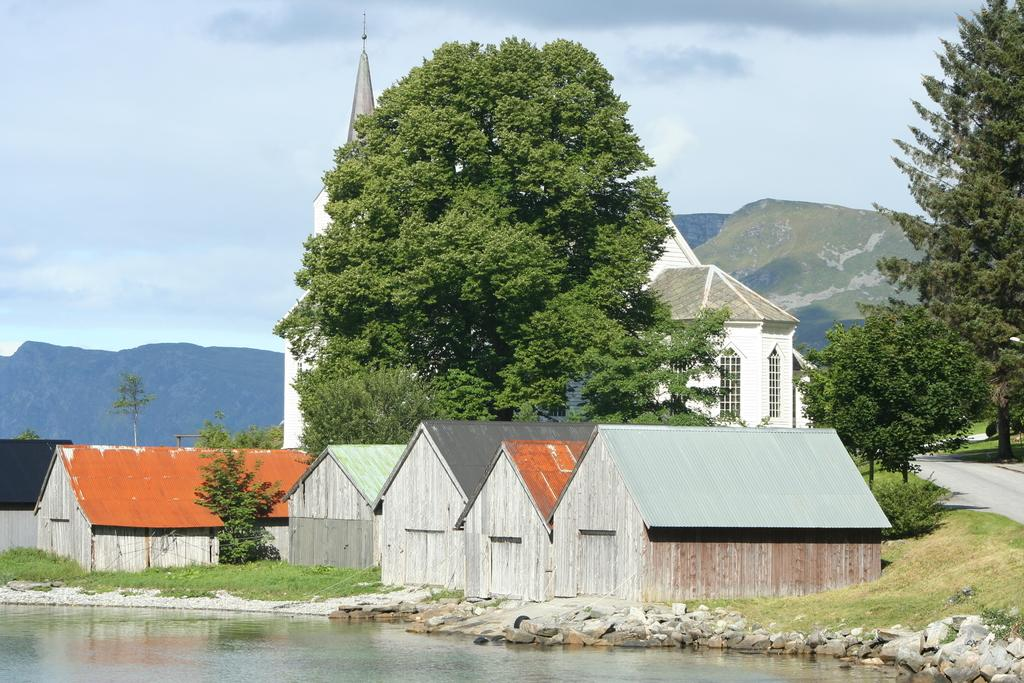What type of surface can be seen in the image? There is a road in the image. What natural element is visible in the image? There is water visible in the image. What type of terrain is present in the image? There are stones, grass, and trees in the image. What geographical feature can be seen in the distance? There are mountains in the image. What part of the sky is visible in the image? The sky is visible in the image. How many feet are visible in the image? There are no feet present in the image. What type of chalk is being used to draw on the road in the image? There is no chalk or drawing on the road in the image. 